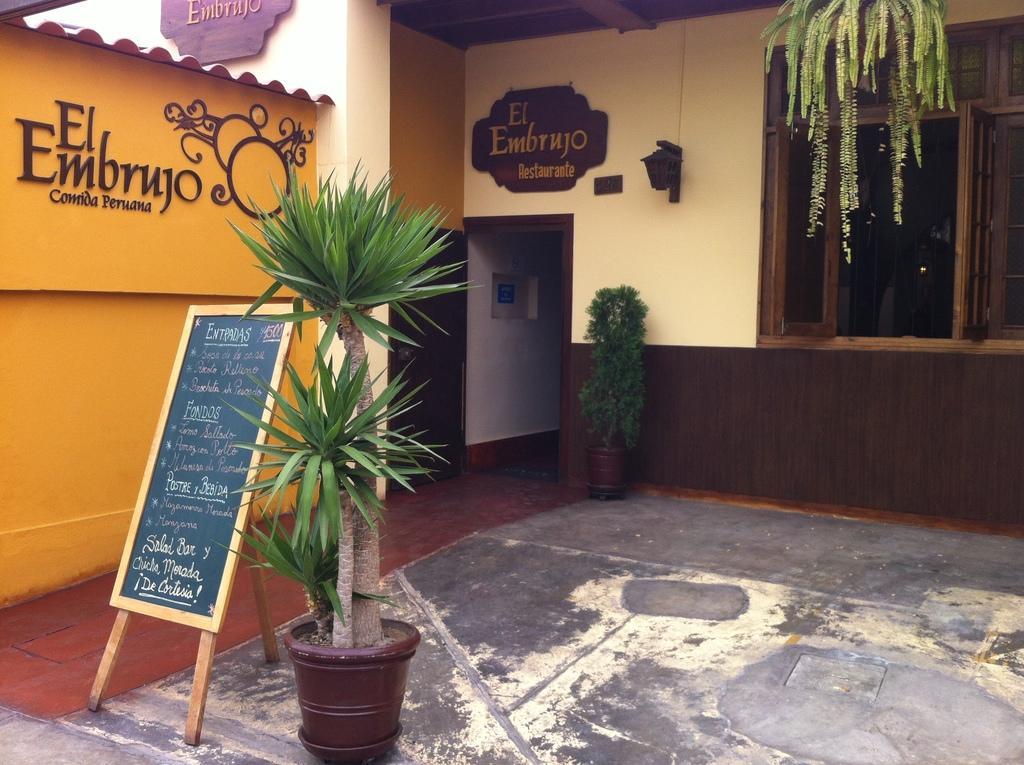Could you give a brief overview of what you see in this image? As we can see in the image there is a house, plants, pot, board and windows. 